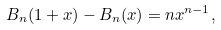<formula> <loc_0><loc_0><loc_500><loc_500>B _ { n } ( 1 + x ) - B _ { n } ( x ) = n x ^ { n - 1 } ,</formula> 